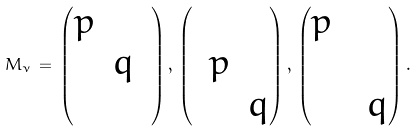Convert formula to latex. <formula><loc_0><loc_0><loc_500><loc_500>M _ { \nu } \, = \, \begin{pmatrix} p & & \\ & q & \\ & & \end{pmatrix} , \, \begin{pmatrix} & & \\ & p & \\ & & q \end{pmatrix} , \, \begin{pmatrix} p & & \\ & & \\ & & q \end{pmatrix} .</formula> 